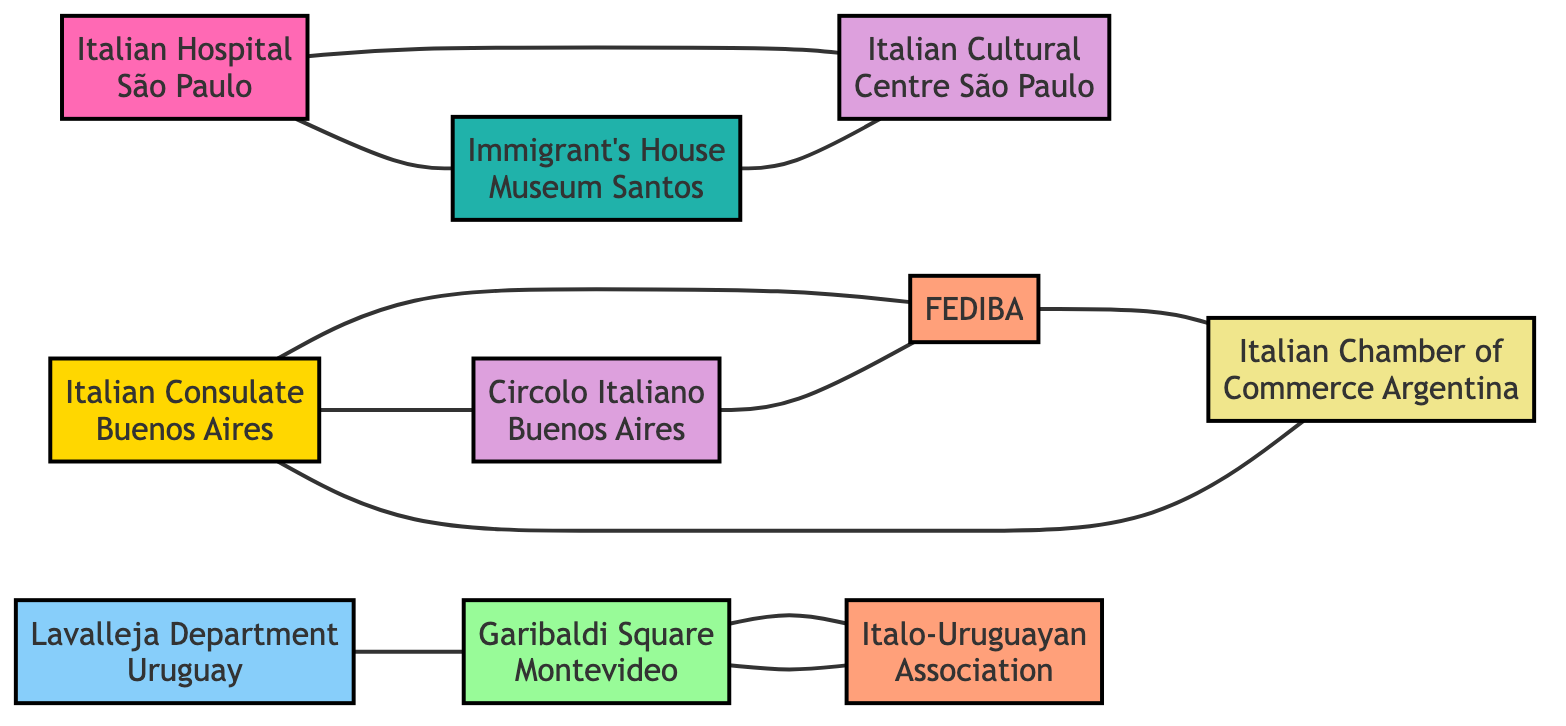What is the total number of nodes in the graph? The graph has 10 nodes listed under the "nodes" section in the data provided.
Answer: 10 What is the label of node 3? The label for node 3 is "Italian Hospital of São Paulo" as specified in the node list.
Answer: Italian Hospital of São Paulo Which cultural center is directly connected to the Italian Hospital of São Paulo? The Italian Cultural Centre of São Paulo is directly connected to the Italian Hospital of São Paulo according to the edges provided.
Answer: Italian Cultural Centre of São Paulo How many edges are connected to the Italian Consulate in Buenos Aires? The Italian Consulate in Buenos Aires is connected to three edges: one to the FEDIBA, one to the Circolo Italiano, and one to the Italian Chamber of Commerce in Argentina.
Answer: 3 What cultural site connects the Immigrant's House Museum in Santos? The Immigrant's House Museum is connected to the Italian Cultural Centre of São Paulo according to the edges listed in the data.
Answer: Italian Cultural Centre of São Paulo Which two nodes are connected to Garibaldi Square in Montevideo? Garibaldi Square connects to the Italo-Uruguayan Association and the Lavalleja Department. After reviewing the edges, both connections are identified.
Answer: Italo-Uruguayan Association, Lavalleja Department What is the relationship between the Federation of Italian Associations in Argentina and the Italian Chamber of Commerce in Argentina? The Federation of Italian Associations in Argentina and the Italian Chamber of Commerce in Argentina are directly connected by an edge, indicating a direct relationship.
Answer: Direct connection How many total cultural or heritage sites are linked to the Italian Consulate in Buenos Aires? The Italian Consulate in Buenos Aires is linked to two cultural sites: the Circolo Italiano and the Federation of Italian Associations in Argentina, making a total of two cultural heritage connections.
Answer: 2 Which node serves as a bridge between the Italian Hospital of São Paulo and the Immigrant's House Museum, Santos? The Italian Cultural Centre of São Paulo serves as a bridge, connecting the Italian Hospital of São Paulo to the Immigrant's House Museum.
Answer: Italian Cultural Centre of São Paulo What type of node connects both Lavalleja Department and Garibaldi Square? The Lavalleja Department connects to Garibaldi Square, and both are categorized under urban cultural sites within the diagram context.
Answer: Urban cultural site 